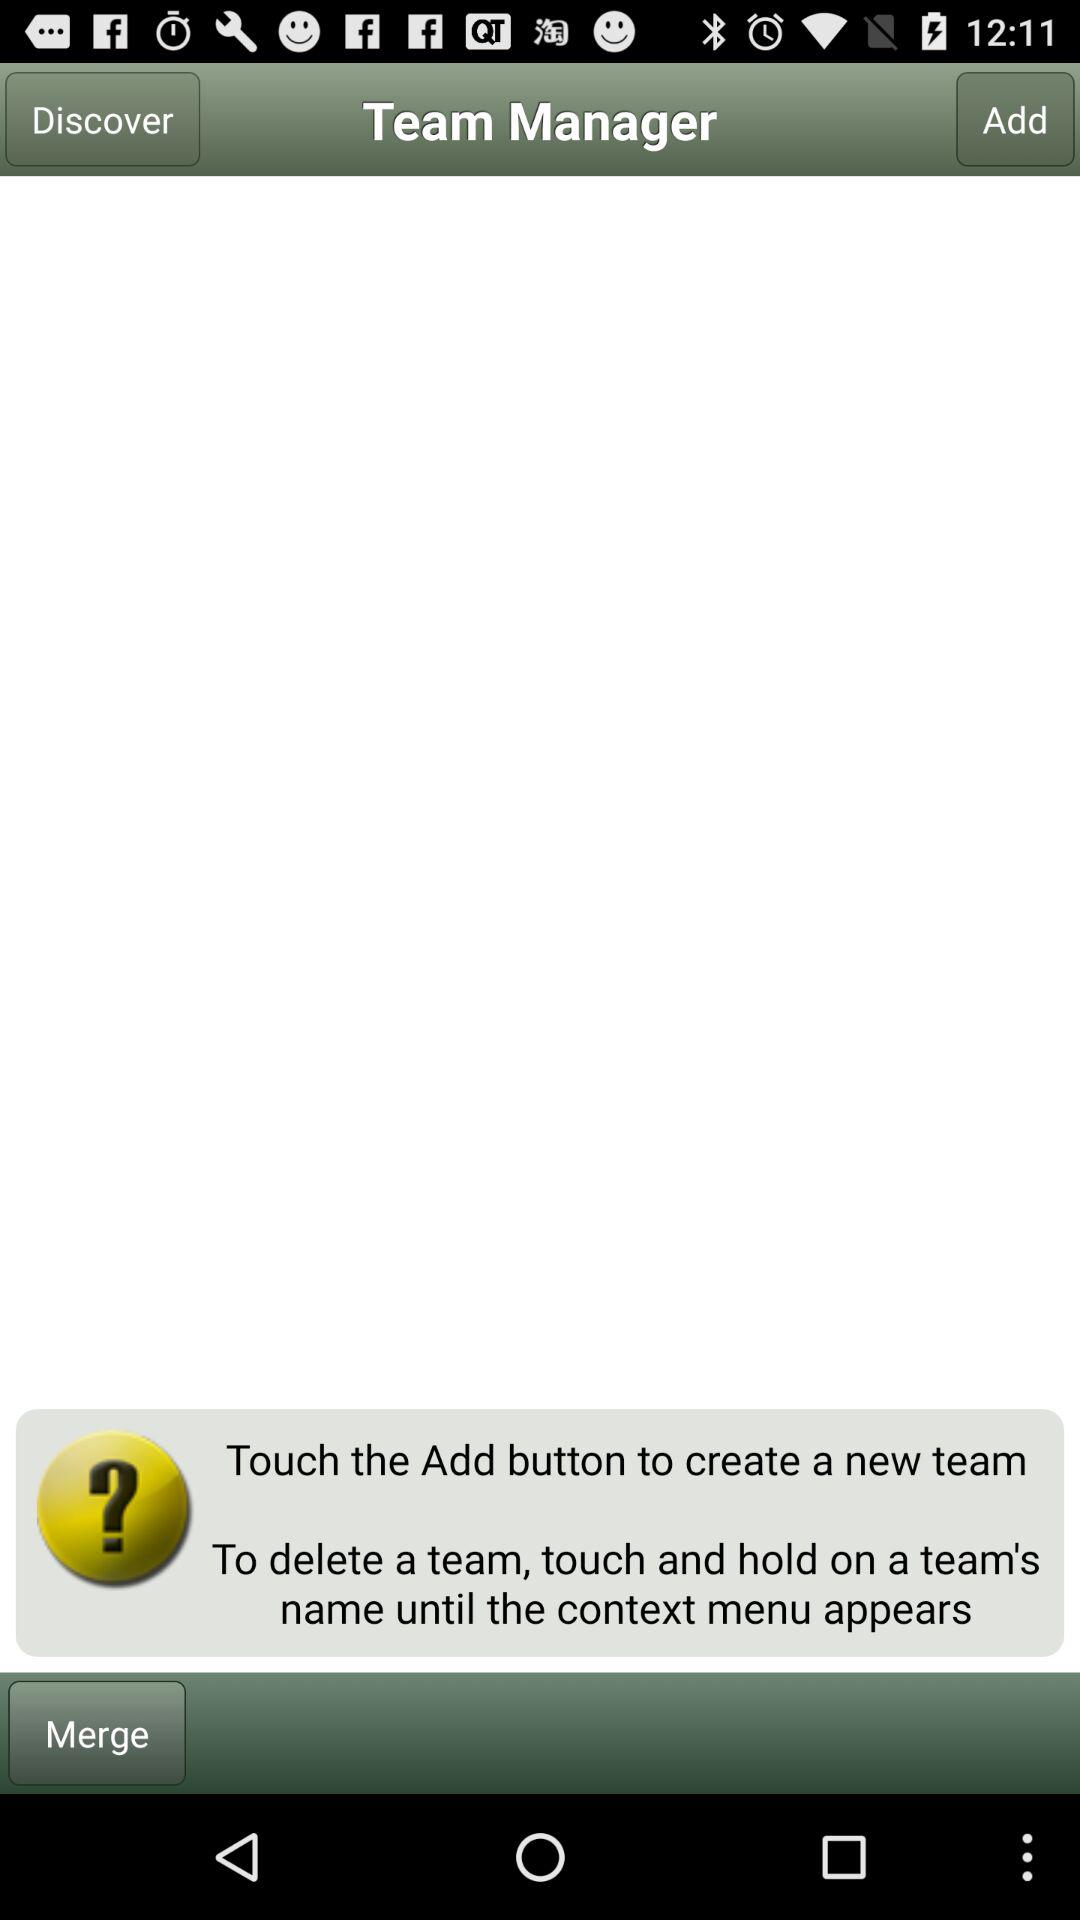How can we delete a team? You can delete a team by touching and holding on a team's name until the context menu appears. 